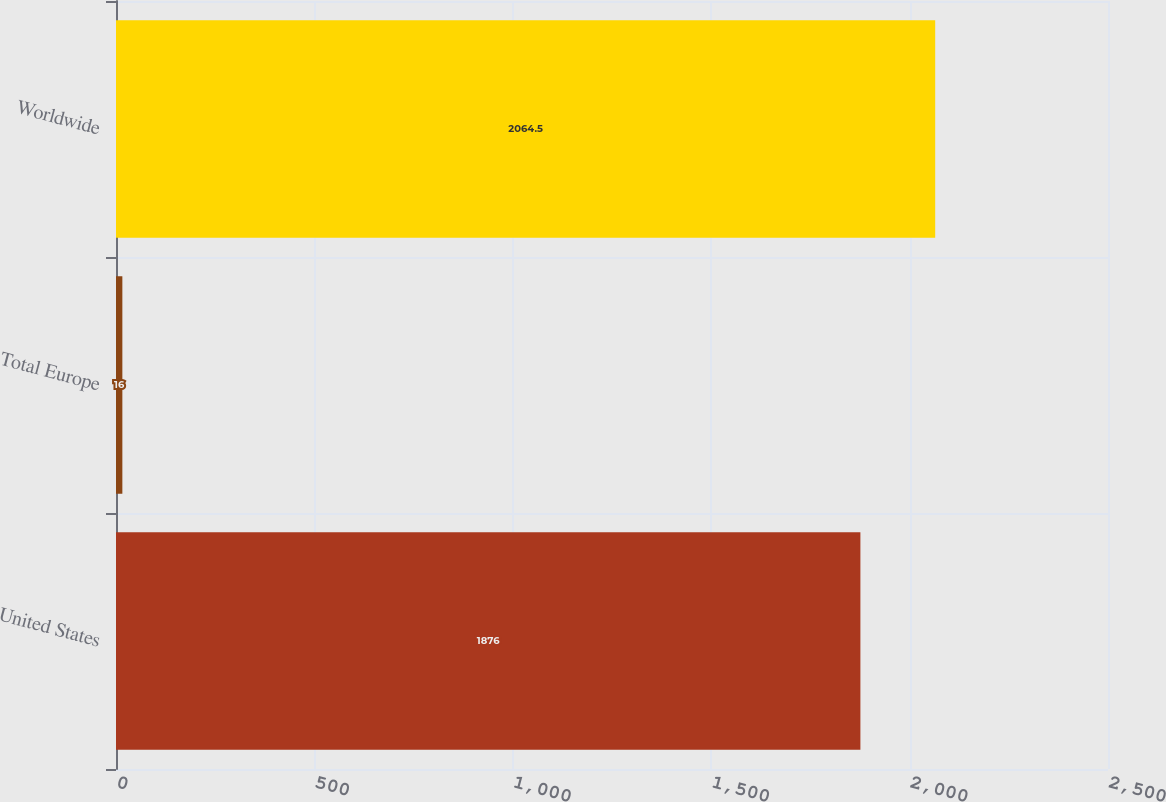Convert chart. <chart><loc_0><loc_0><loc_500><loc_500><bar_chart><fcel>United States<fcel>Total Europe<fcel>Worldwide<nl><fcel>1876<fcel>16<fcel>2064.5<nl></chart> 